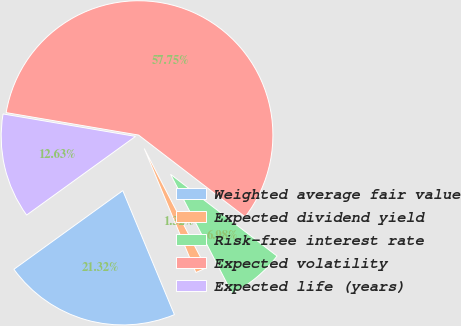Convert chart to OTSL. <chart><loc_0><loc_0><loc_500><loc_500><pie_chart><fcel>Weighted average fair value<fcel>Expected dividend yield<fcel>Risk-free interest rate<fcel>Expected volatility<fcel>Expected life (years)<nl><fcel>21.32%<fcel>1.32%<fcel>6.98%<fcel>57.75%<fcel>12.63%<nl></chart> 